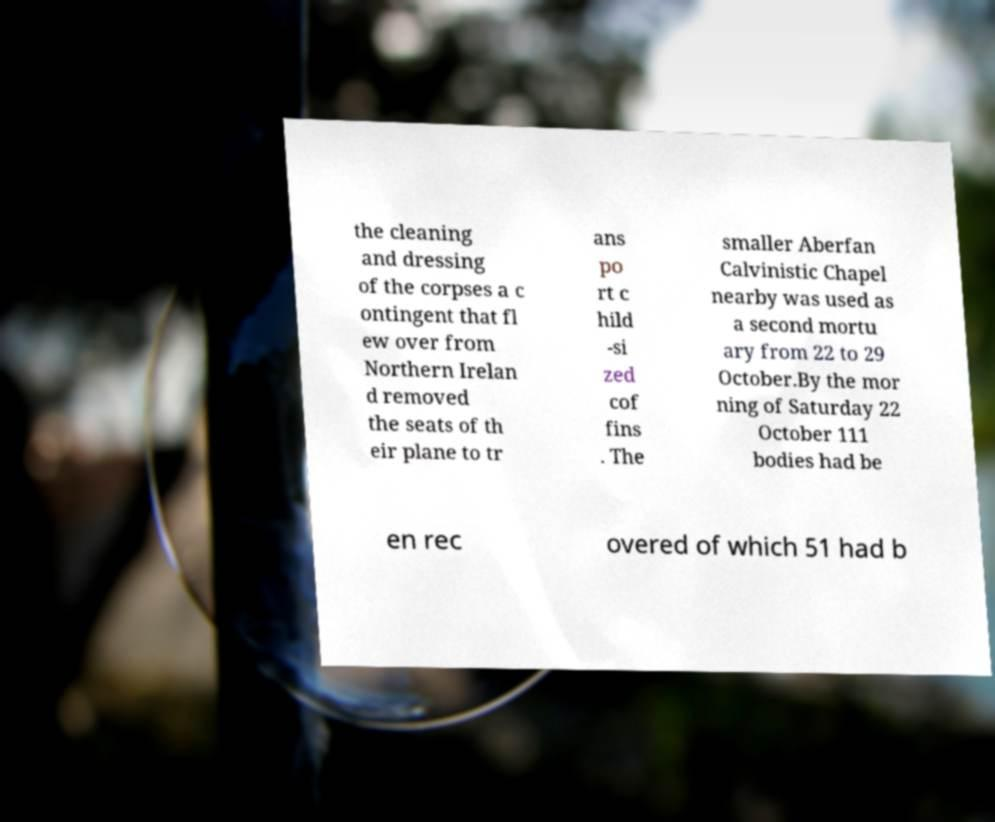Could you assist in decoding the text presented in this image and type it out clearly? the cleaning and dressing of the corpses a c ontingent that fl ew over from Northern Irelan d removed the seats of th eir plane to tr ans po rt c hild -si zed cof fins . The smaller Aberfan Calvinistic Chapel nearby was used as a second mortu ary from 22 to 29 October.By the mor ning of Saturday 22 October 111 bodies had be en rec overed of which 51 had b 